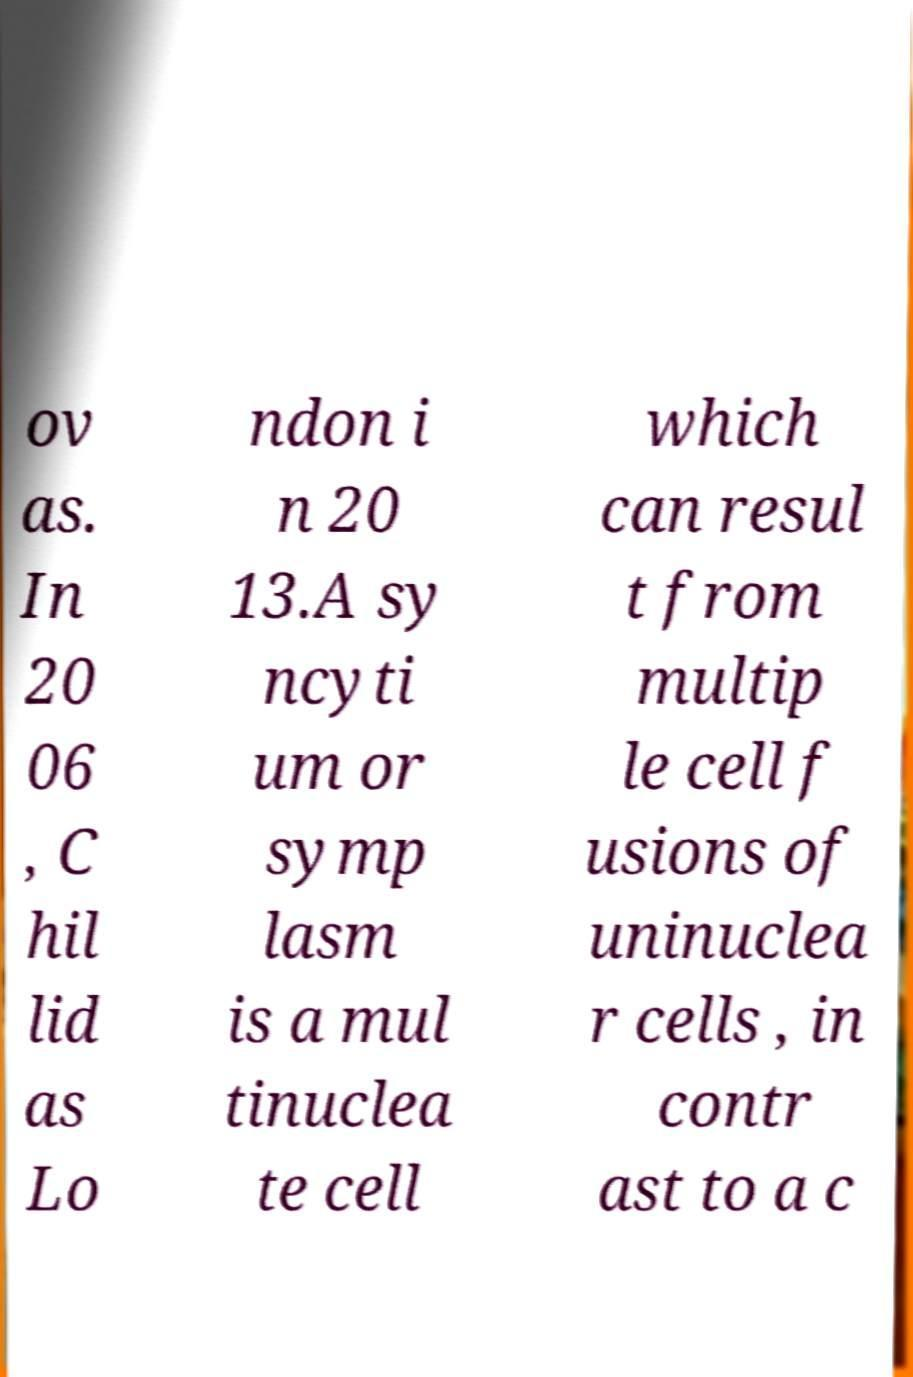For documentation purposes, I need the text within this image transcribed. Could you provide that? ov as. In 20 06 , C hil lid as Lo ndon i n 20 13.A sy ncyti um or symp lasm is a mul tinuclea te cell which can resul t from multip le cell f usions of uninuclea r cells , in contr ast to a c 